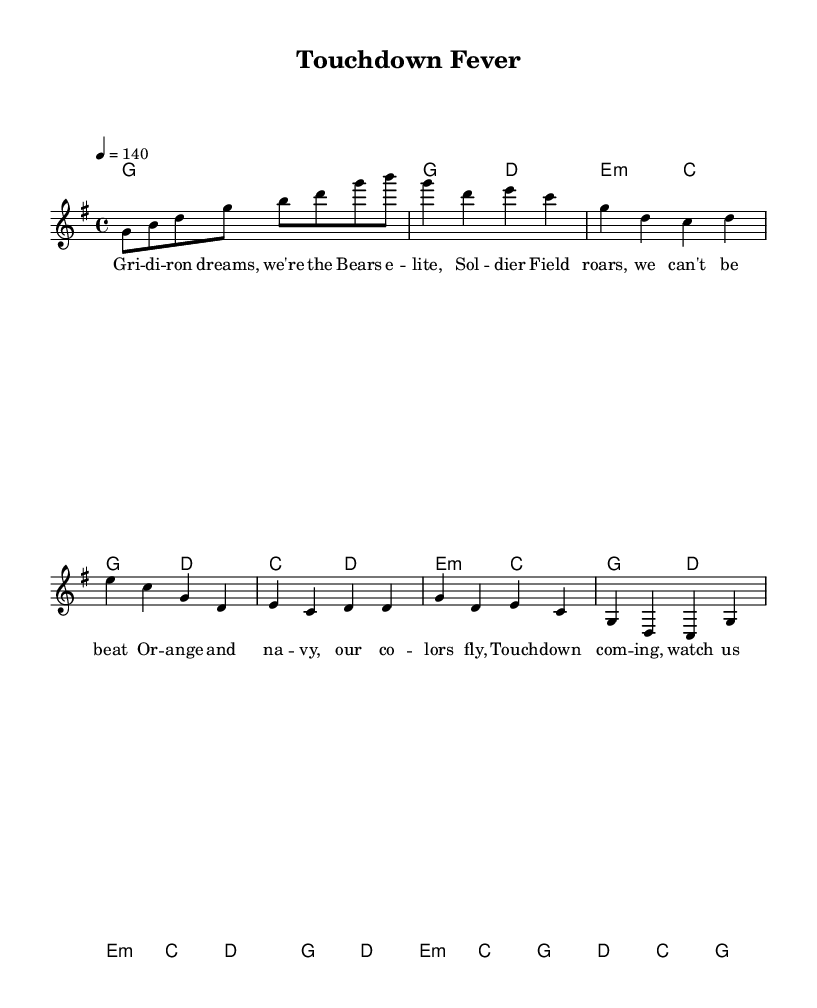What is the key signature of this music? The key signature is G major, which has one sharp (F#), visible in the key signature at the beginning of the staff.
Answer: G major What is the time signature of this music? The time signature is 4/4, indicated at the beginning of the score, meaning there are four beats in each measure and the quarter note gets one beat.
Answer: 4/4 What is the tempo marking for this piece? The tempo marking is 140 beats per minute, specified as "4 = 140" in the tempo indication at the beginning of the score.
Answer: 140 How many measures are in the chorus section? The chorus section consists of four measures, identifiable by the section labeled in the music. Count each measure in the chorus section to determine this.
Answer: 4 What are the predominant themes in the lyrics? The predominant themes in the lyrics are football and team spirit, which emphasize supporting the Chicago Bears and celebrating touchdowns.
Answer: Football and team spirit Which chords are used in the pre-chorus? The chords used in the pre-chorus are E minor and C major, as shown in the chord mode section below the melody for that part.
Answer: E minor and C major What kind of song structure is present here? The song follows a common pop structure with verses, a pre-chorus, and a chorus, which builds momentum and excitement typical of upbeat K-Pop songs.
Answer: Verse, pre-chorus, chorus 